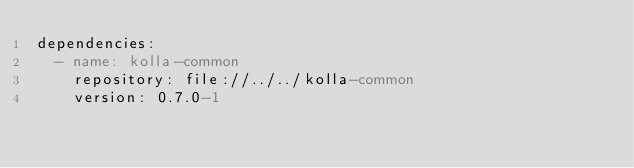Convert code to text. <code><loc_0><loc_0><loc_500><loc_500><_YAML_>dependencies:
  - name: kolla-common
    repository: file://../../kolla-common
    version: 0.7.0-1
</code> 